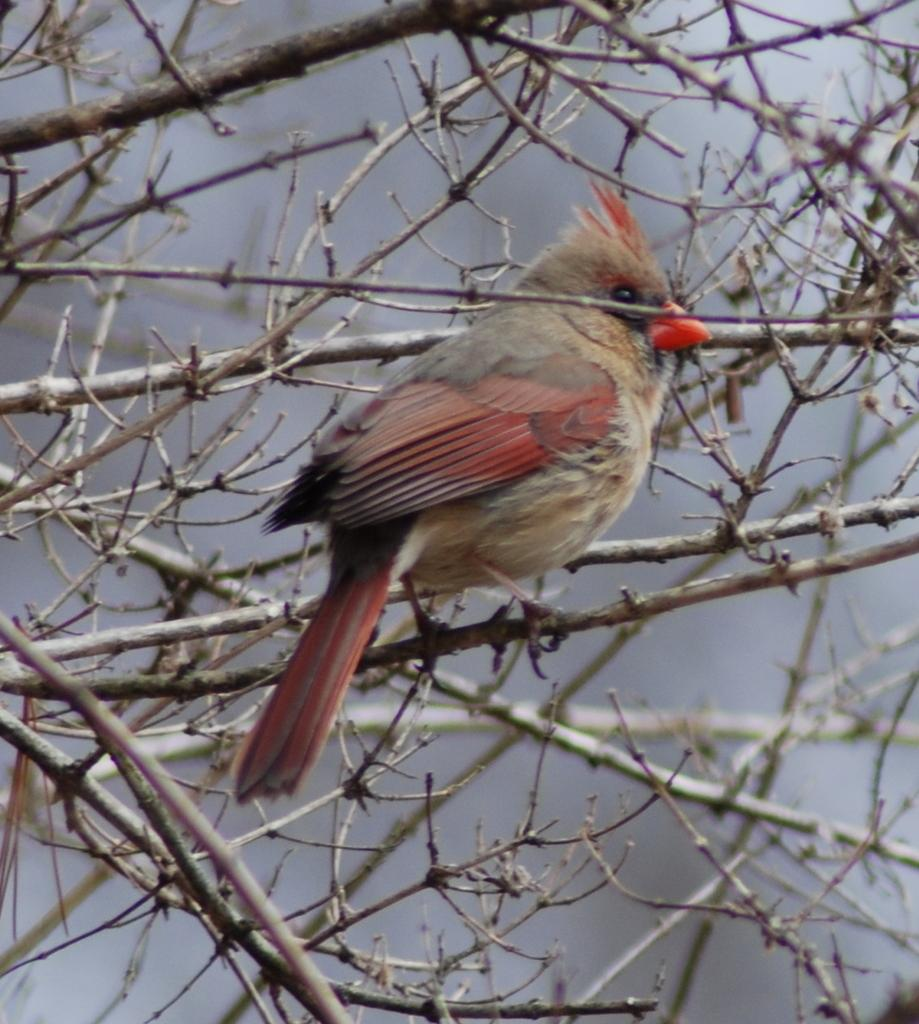What type of animal is in the image? There is a bird in the image. Where is the bird located in the image? The bird is on a branch. What type of laborer is depicted in the image? There is no laborer present in the image; it features a bird on a branch. What kind of ornament is hanging from the branch in the image? There is no ornament present in the image; it only features a bird on a branch. 